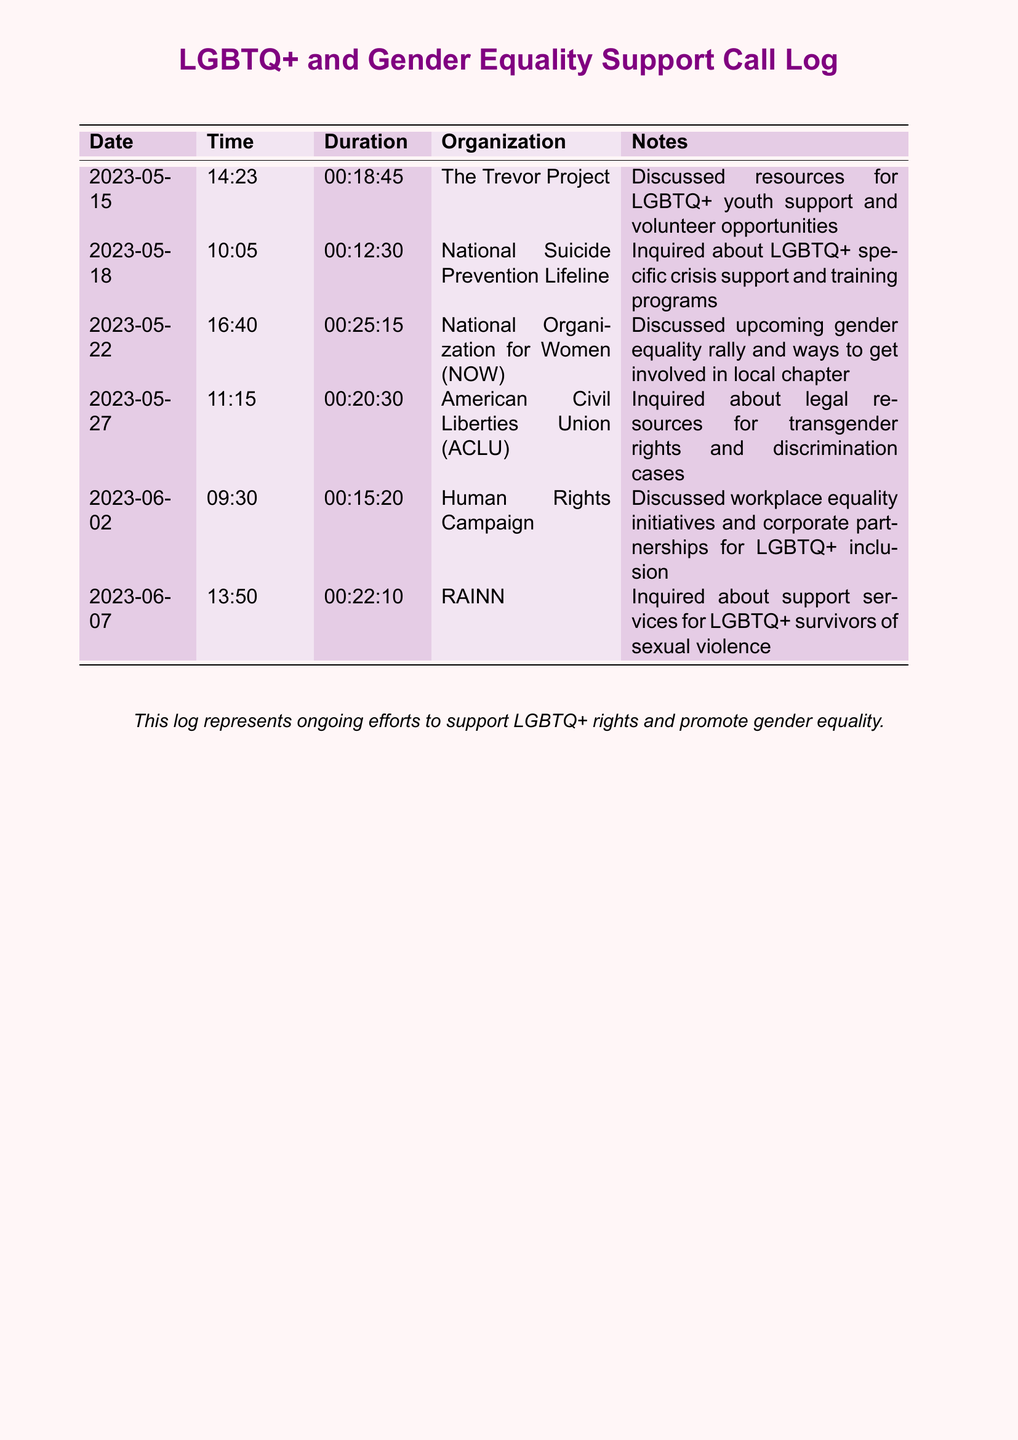What is the date of the first call? The date of the first call is included in the log as 2023-05-15.
Answer: 2023-05-15 How long was the call with The Trevor Project? The duration of the call with The Trevor Project is shown as 00:18:45.
Answer: 00:18:45 Which organization was contacted on May 22? The organization contacted on May 22 is specified as the National Organization for Women (NOW).
Answer: National Organization for Women (NOW) What was discussed during the call with RAINN? The notes for the call with RAINN mention support services for LGBTQ+ survivors of sexual violence.
Answer: Support services for LGBTQ+ survivors of sexual violence How many calls were made to LGBTQ+ organizations? The number of calls made to LGBTQ+ organizations can be counted from the log, which lists six calls in total.
Answer: 6 What is the common topic among the organizations contacted? The common topic is related to LGBTQ+ rights and gender equality, based on the notes in the document.
Answer: LGBTQ+ rights and gender equality Which organization discussed workplace equality initiatives? The organization that discussed workplace equality initiatives is the Human Rights Campaign.
Answer: Human Rights Campaign What was the time of the call with the ACLU? The time of the call with the ACLU is recorded as 11:15.
Answer: 11:15 